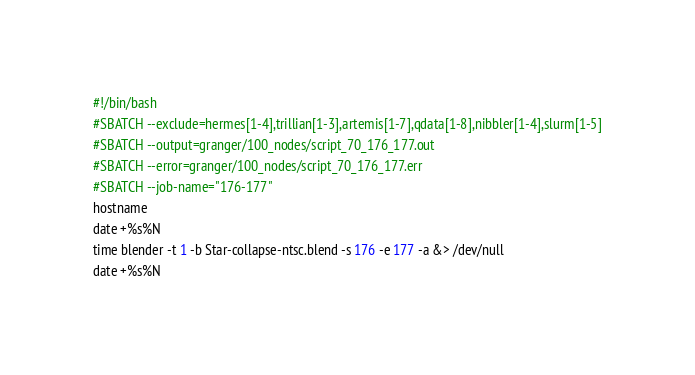Convert code to text. <code><loc_0><loc_0><loc_500><loc_500><_Bash_>#!/bin/bash
#SBATCH --exclude=hermes[1-4],trillian[1-3],artemis[1-7],qdata[1-8],nibbler[1-4],slurm[1-5]
#SBATCH --output=granger/100_nodes/script_70_176_177.out
#SBATCH --error=granger/100_nodes/script_70_176_177.err
#SBATCH --job-name="176-177"
hostname
date +%s%N
time blender -t 1 -b Star-collapse-ntsc.blend -s 176 -e 177 -a &> /dev/null
date +%s%N
</code> 